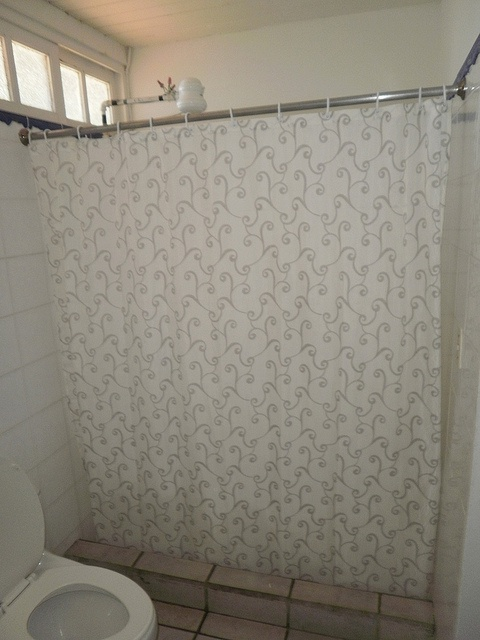Describe the objects in this image and their specific colors. I can see a toilet in gray tones in this image. 